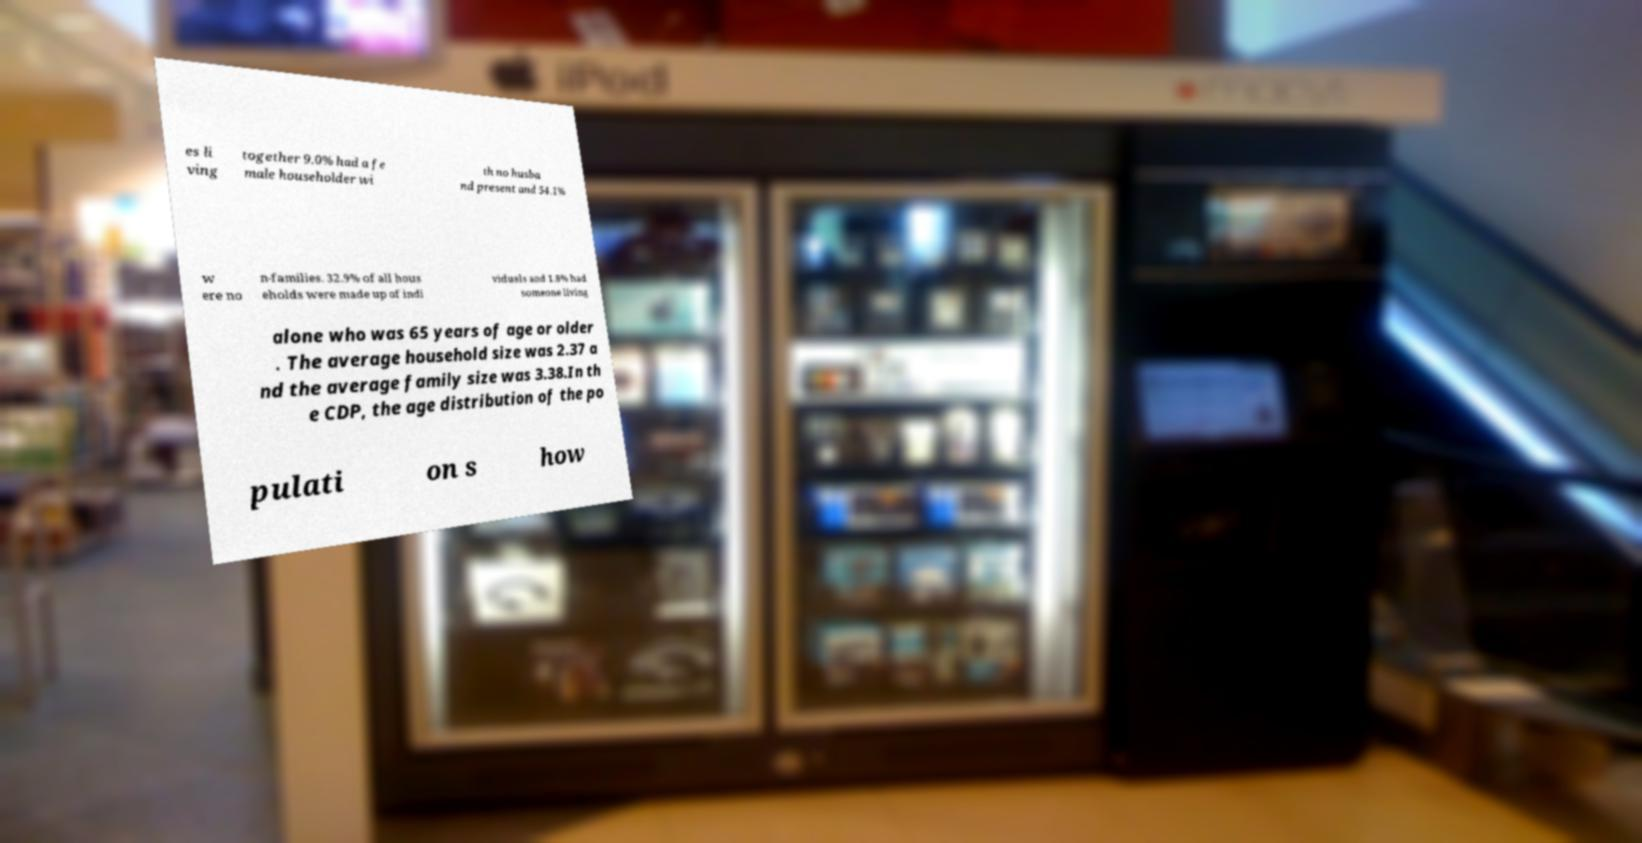Could you extract and type out the text from this image? es li ving together 9.0% had a fe male householder wi th no husba nd present and 54.1% w ere no n-families. 32.9% of all hous eholds were made up of indi viduals and 1.8% had someone living alone who was 65 years of age or older . The average household size was 2.37 a nd the average family size was 3.38.In th e CDP, the age distribution of the po pulati on s how 